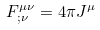<formula> <loc_0><loc_0><loc_500><loc_500>F ^ { \mu \nu } _ { ; \nu } = 4 \pi J ^ { \mu }</formula> 